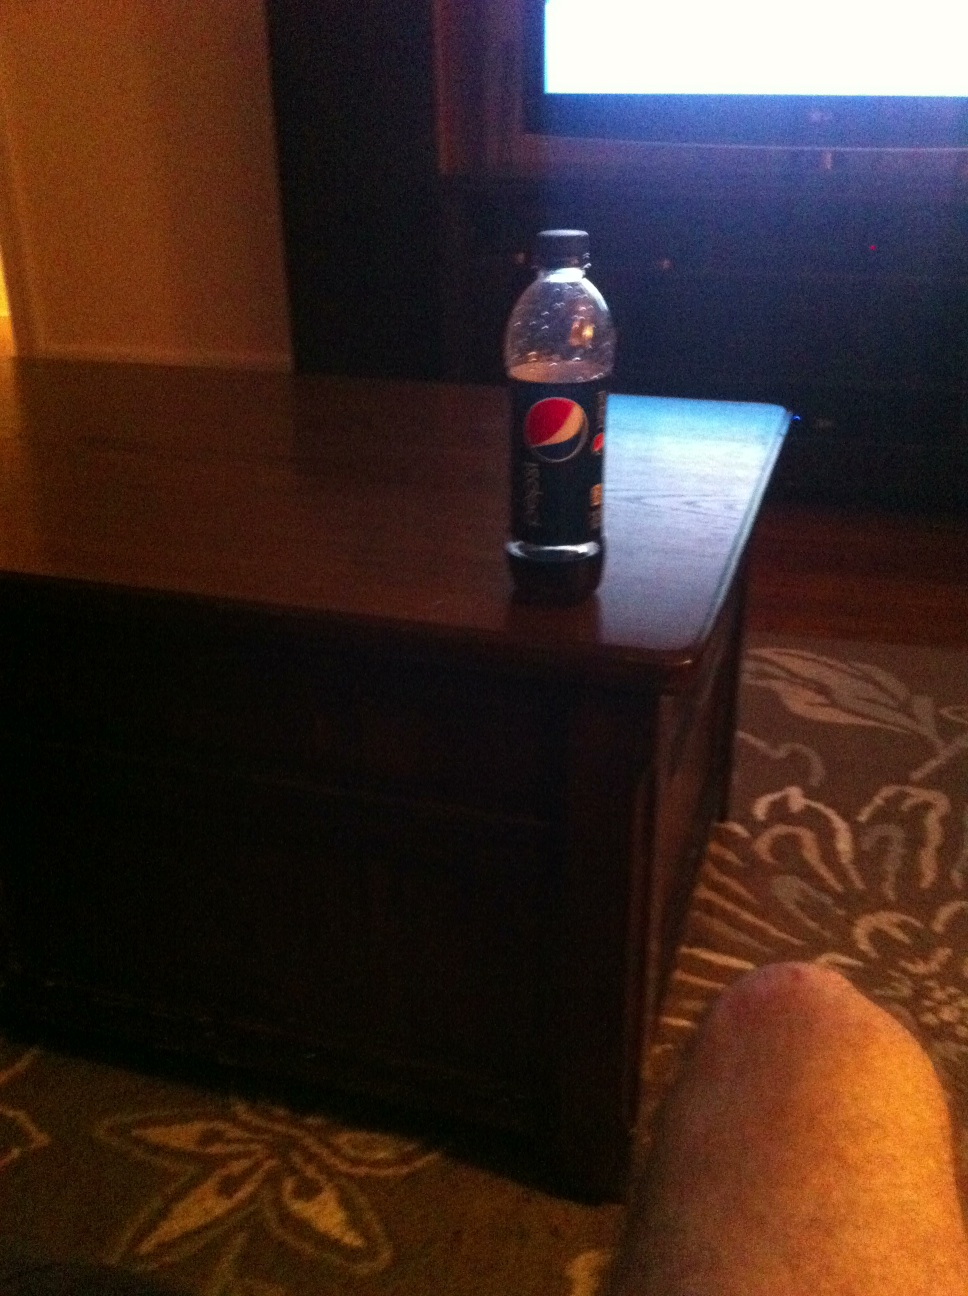What is this a picture of? from Vizwiz This is a picture of a bottle of Pepsi placed on a coffee table. The lighting is dim, likely indoor, and part of a human leg is visible, suggesting a casual, relaxed setting. 